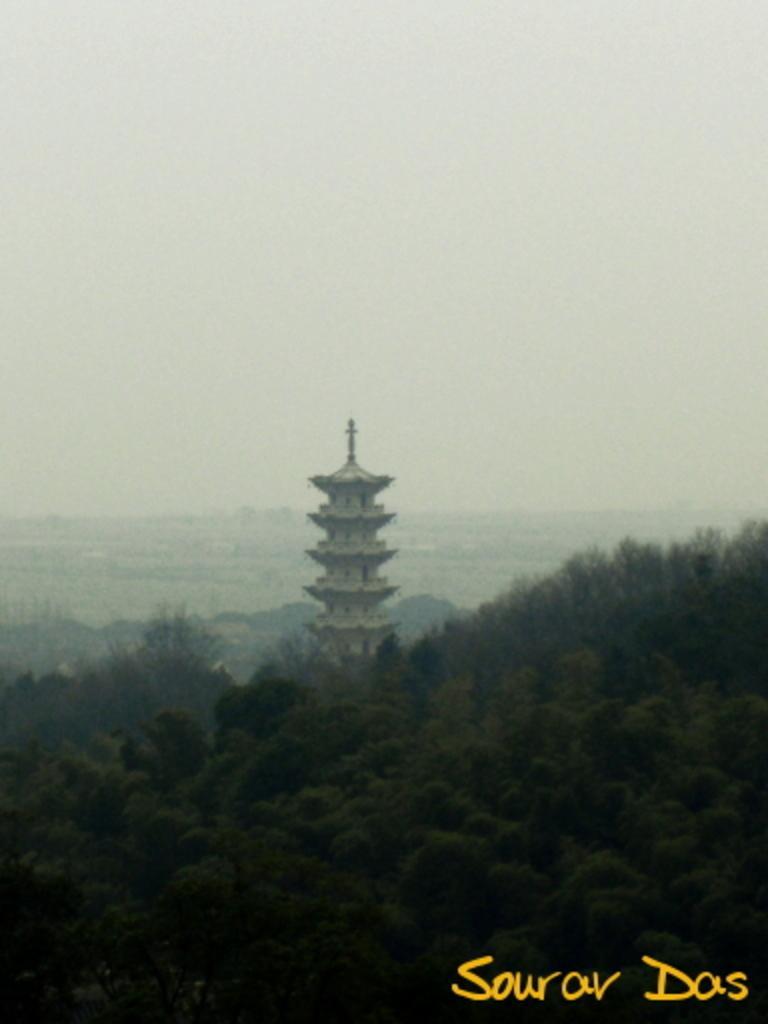In one or two sentences, can you explain what this image depicts? In the image we can see there is a building and there are lot of trees. There is clear sky on the top. 